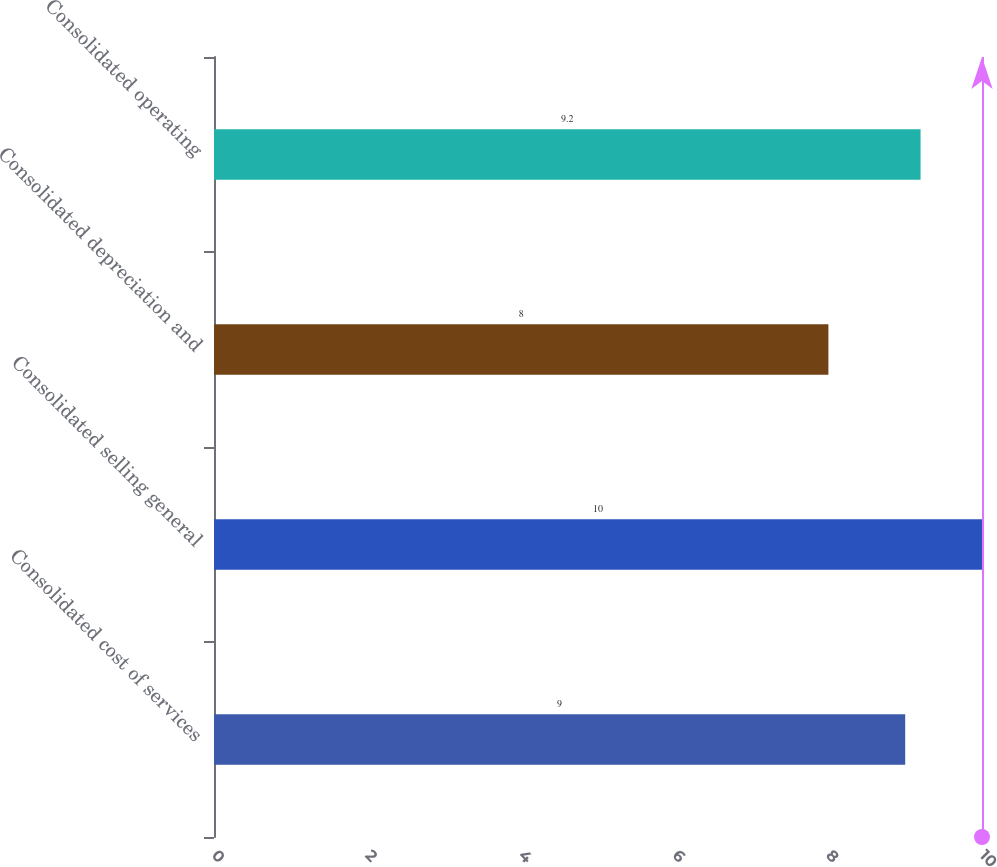Convert chart to OTSL. <chart><loc_0><loc_0><loc_500><loc_500><bar_chart><fcel>Consolidated cost of services<fcel>Consolidated selling general<fcel>Consolidated depreciation and<fcel>Consolidated operating<nl><fcel>9<fcel>10<fcel>8<fcel>9.2<nl></chart> 